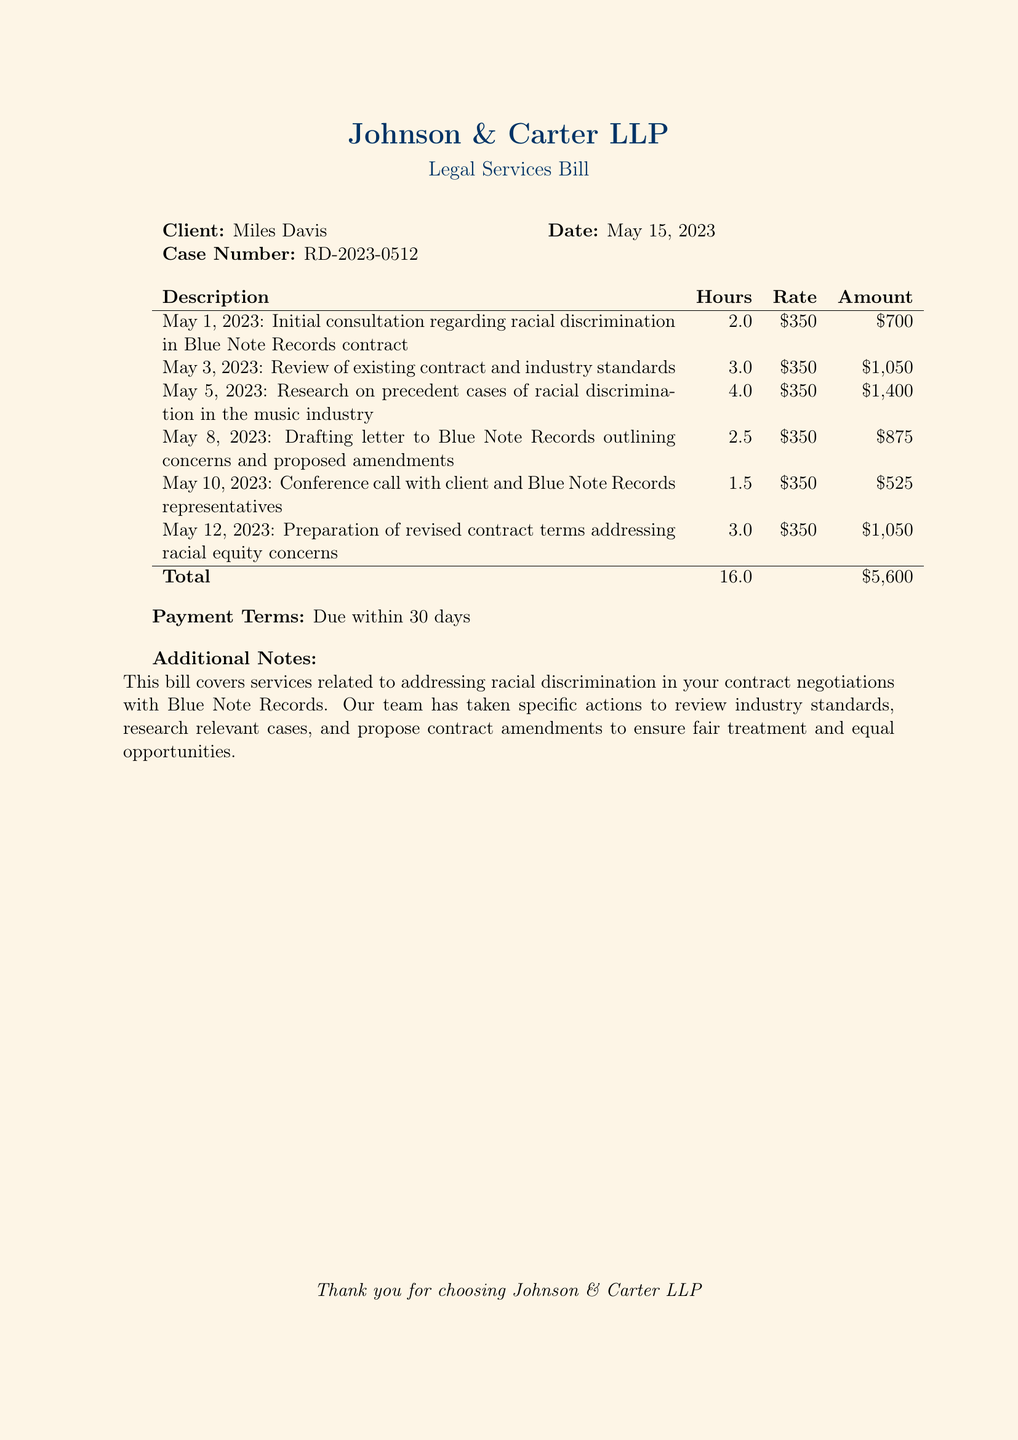What is the client’s name? The client's name is specified at the beginning of the document under the Client section.
Answer: Miles Davis What is the date of the legal services bill? The date is indicated on the bill in the Date section.
Answer: May 15, 2023 How many hours were spent on drafting a letter to Blue Note Records? The hours for specific tasks are listed in the billing table; the specific task in question is noted.
Answer: 2.5 What is the total amount due for the services rendered? The total amount is calculated and presented at the bottom of the billing table.
Answer: $5,600 What action was taken on May 3, 2023? This date reflects an action regarding the review, as noted in the Description section of the billing table.
Answer: Review of existing contract and industry standards How many hours were dedicated to researching precedent cases? The carefully filled hours for that operation reflect the time spent on research.
Answer: 4.0 What are the payment terms stated in the document? The payment terms are explicitly stated under a relevant section of the document.
Answer: Due within 30 days What was the purpose of the consultation on May 1, 2023? The purpose is described in the Description line corresponding to that date in the billing table.
Answer: Racial discrimination in Blue Note Records contract What is the case number listed in the document? The case number is stated alongside the client's name in the document.
Answer: RD-2023-0512 